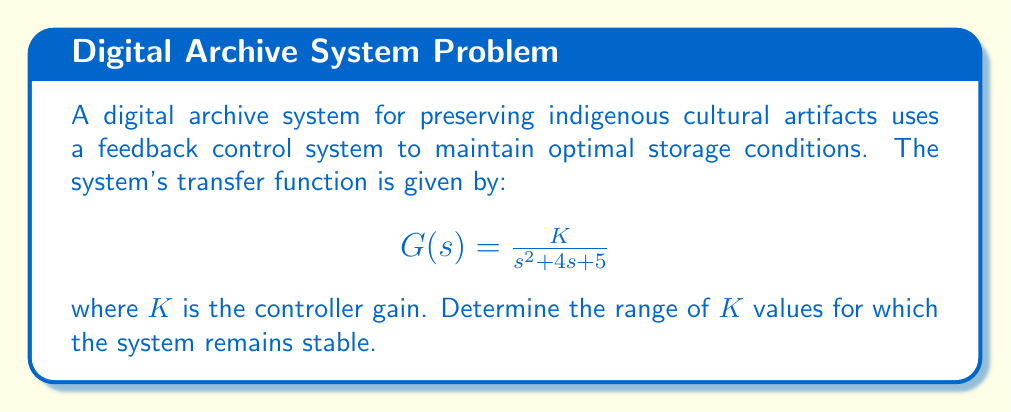Give your solution to this math problem. To analyze the stability of this feedback control system, we'll use the Routh-Hurwitz stability criterion. This method helps determine the stability of a linear time-invariant (LTI) system without solving for the roots of the characteristic equation.

Steps:

1. First, we need to form the closed-loop transfer function. The characteristic equation of the closed-loop system is:

   $$1 + G(s) = 0$$

   Substituting $G(s)$:

   $$1 + \frac{K}{s^2 + 4s + 5} = 0$$

2. Multiply both sides by the denominator:

   $$s^2 + 4s + 5 + K = 0$$

3. This is our characteristic equation. Now we can form the Routh array:

   $$\begin{array}{c|cc}
   s^2 & 1 & 5 \\
   s^1 & 4 & K \\
   s^0 & 5 - \frac{K}{4} & 0
   \end{array}$$

4. For stability, all elements in the first column of the Routh array must be positive. We already know that the first two elements (1 and 4) are positive, so we need to ensure that the last element is also positive:

   $$5 - \frac{K}{4} > 0$$

5. Solving this inequality:

   $$5 - \frac{K}{4} > 0$$
   $$-\frac{K}{4} > -5$$
   $$K < 20$$

6. Since $K$ represents a gain, it must be positive. Therefore, the range of $K$ for stability is:

   $$0 < K < 20$$

This range ensures that all roots of the characteristic equation have negative real parts, maintaining system stability.
Answer: The system remains stable for $0 < K < 20$. 